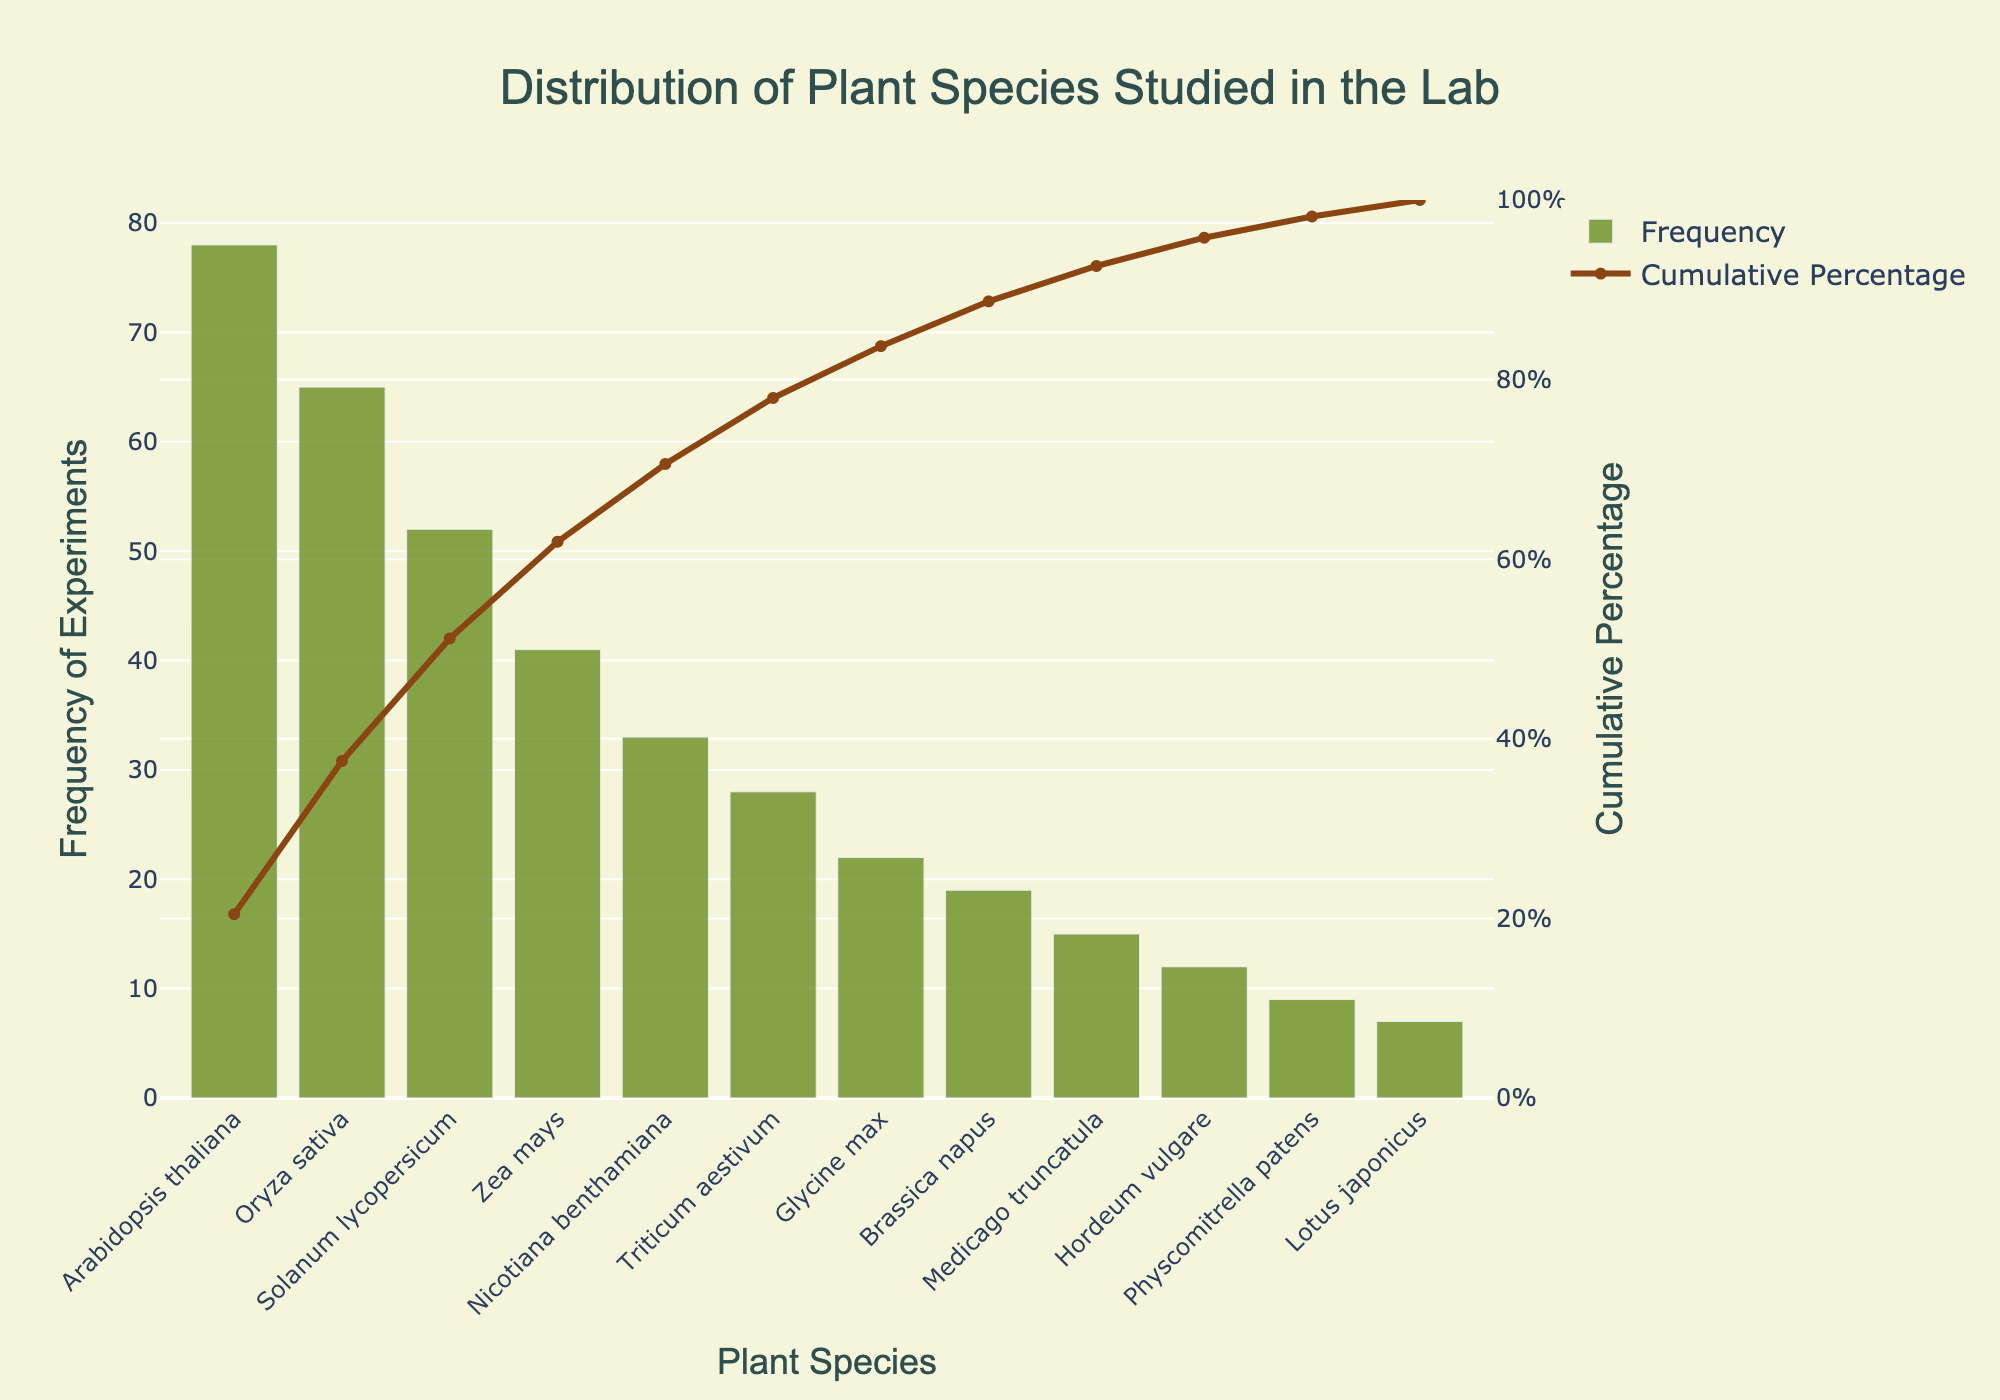What is the title of the chart? The title is generally located at the top of the chart in a larger and more prominent font size, making it clear to the viewer.
Answer: Distribution of Plant Species Studied in the Lab Which plant species has the highest frequency of experiments? By observing the height of the bars, the highest bar represents the plant species with the most frequent experiments, located at the far left of the chart.
Answer: Arabidopsis thaliana What is the cumulative percentage for Oryza sativa? Locate the bar corresponding to Oryza sativa and follow its position on the x-axis upward to see where it aligns with the cumulative percentage line on the secondary y-axis.
Answer: 41.4% How many plant species have a frequency of experiments greater than 30? Identify the bars that exceed the frequency of 30 on the primary y-axis and count the corresponding plant species along the x-axis.
Answer: 5 What is the cumulative percentage at the point where Nicotiana benthamiana is plotted? Identify the specific bar for Nicotiana benthamiana, then follow its height to the intersection with the cumulative percentage line on the secondary y-axis.
Answer: ~85% Which plant species is studied least frequently? The shortest bar indicates the least frequently studied plant species, which will be located at the far right of the chart.
Answer: Lotus japonicus What's the total frequency of experiments for Arabidopsis thaliana, Oryza sativa, and Solanum lycopersicum combined? Add the frequencies from the respective bars of these three plant species (78 + 65 + 52).
Answer: 195 What is the difference in frequency of experiments between Zea mays and Glycine max? Subtract the frequency of Glycine max from the frequency of Zea mays (41 - 22).
Answer: 19 Which plant species contribute to the top 50% of cumulative frequency? Identify the point where cumulative percentage crosses 50%, then consider all plant species to the left of this point.
Answer: Arabidopsis thaliana, Oryza sativa, Solanum lycopersicum At what cumulative percentage does Hordeum vulgare appear? Identify the bar for Hordeum vulgare, and trace its height to find its intersection with the cumulative percentage on the secondary y-axis.
Answer: 94.7% 